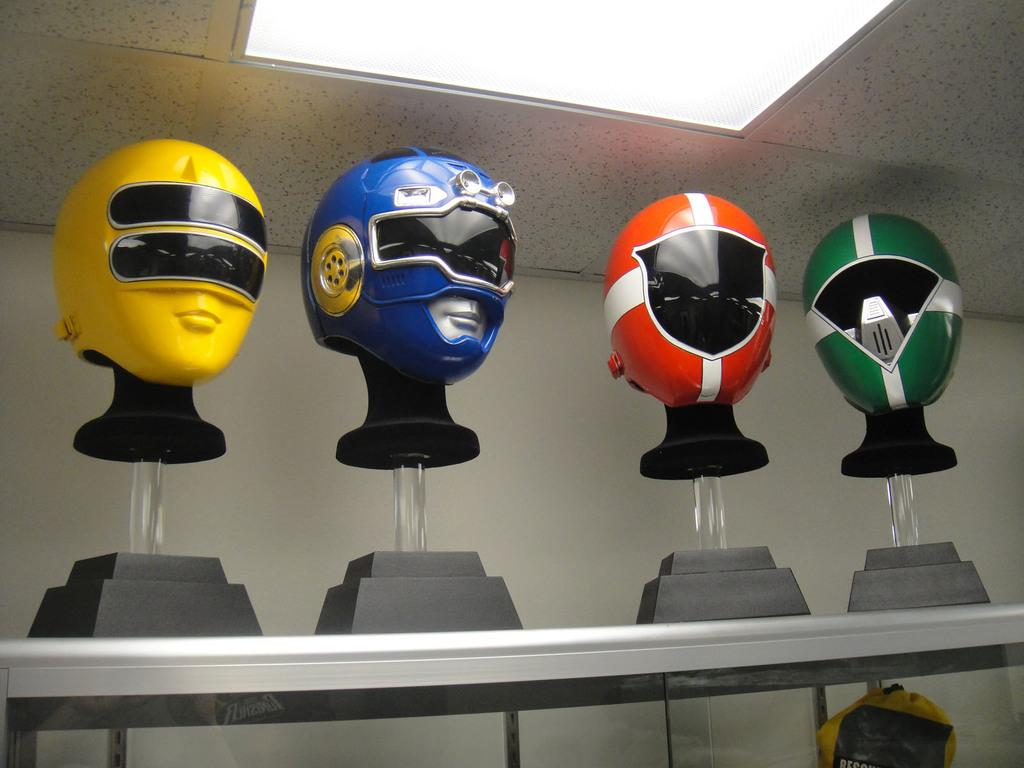What objects are placed on stands in the image? There are helmets placed on stands in the image. What is located at the bottom of the image? There is a table at the bottom of the image. What can be seen in the background of the image? There is a wall in the background of the image. What type of dress is hanging on the wall in the image? There is no dress present in the image; it features helmets placed on stands and a table. How many whistles can be seen on the table in the image? There are no whistles present in the image; it only shows helmets placed on stands and a table. 